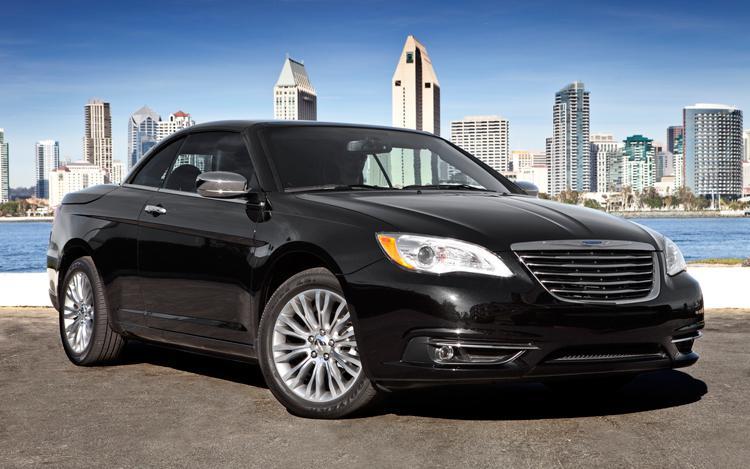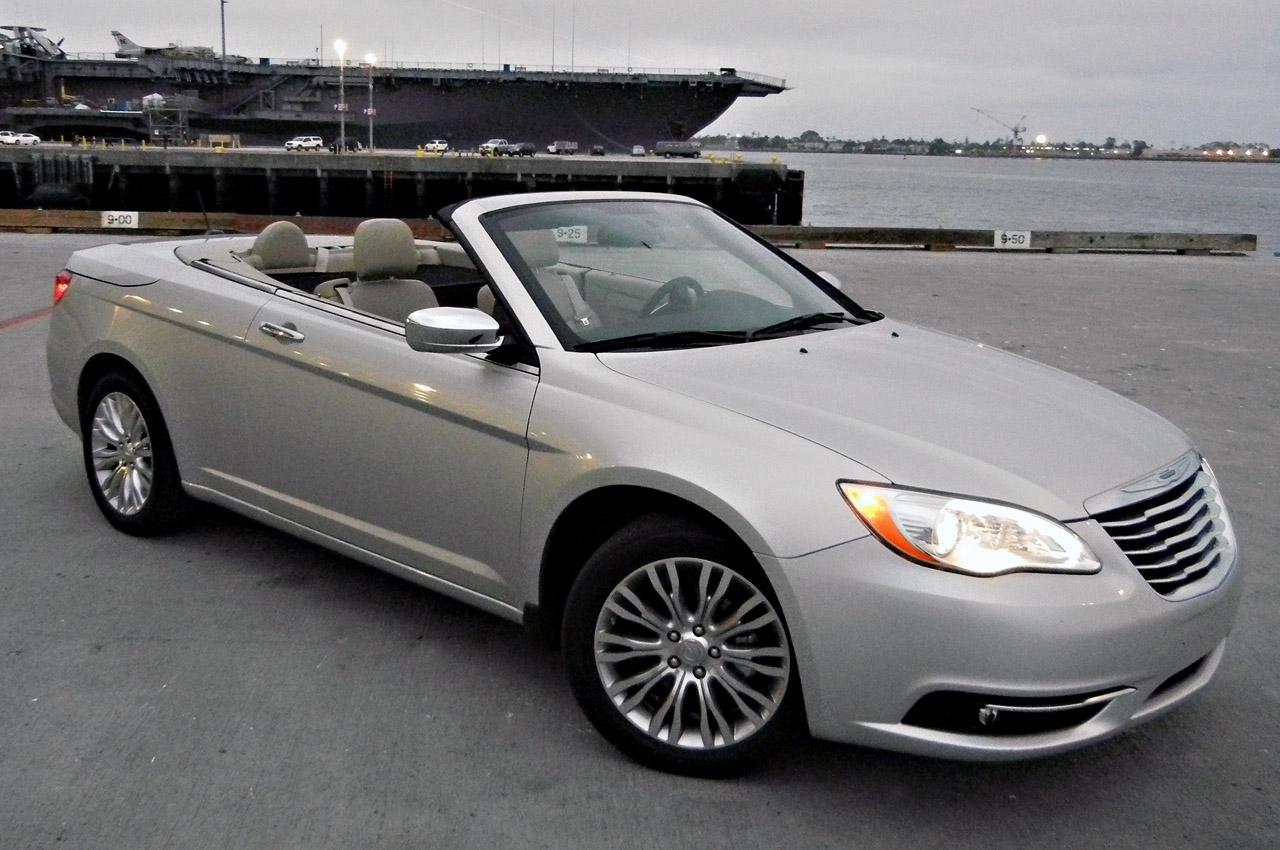The first image is the image on the left, the second image is the image on the right. Considering the images on both sides, is "In the left image, there is a single blue convertible with its top down" valid? Answer yes or no. No. The first image is the image on the left, the second image is the image on the right. Evaluate the accuracy of this statement regarding the images: "The left image contains only one car and it is blue.". Is it true? Answer yes or no. No. 